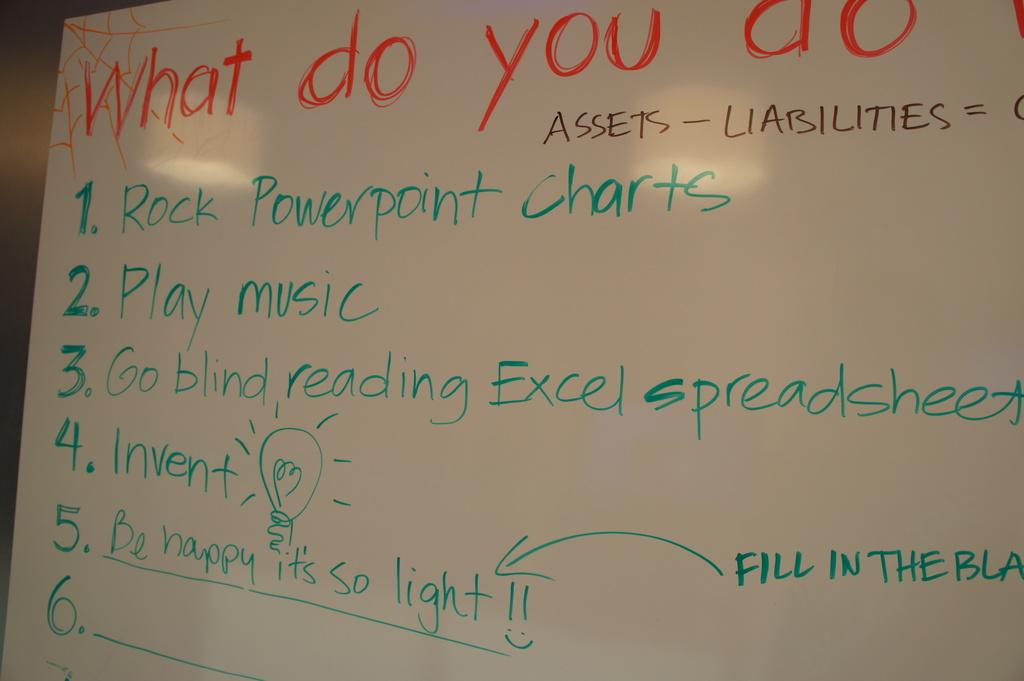<image>
Share a concise interpretation of the image provided. A whiteboard lists out activities like play music and rock powerpoint charts. 